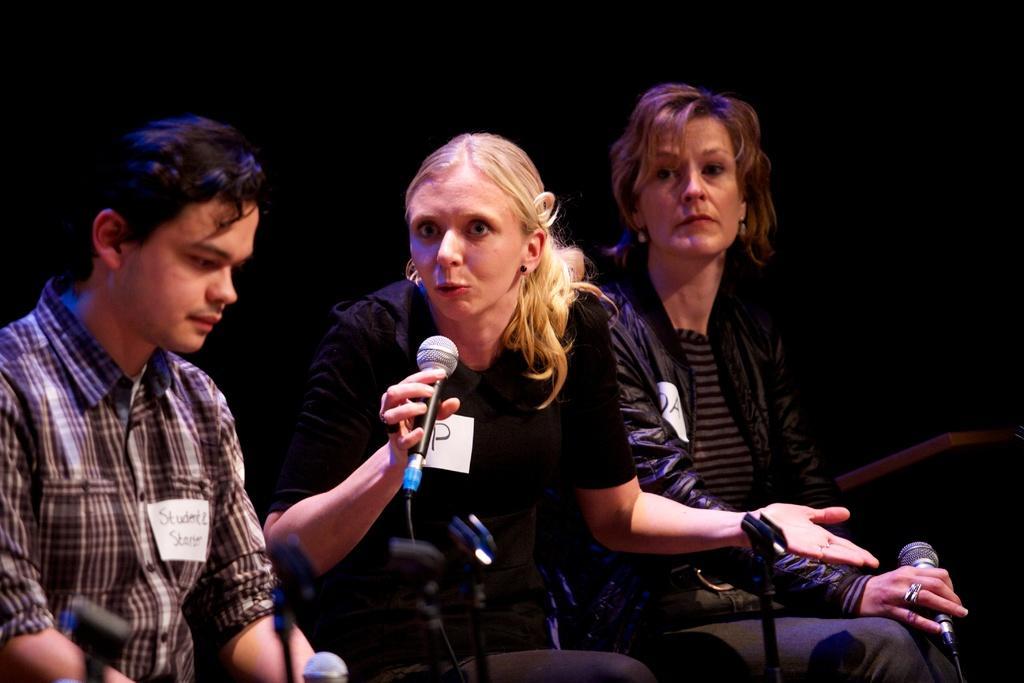Can you describe this image briefly? The woman in the middle of the picture wearing black t-shirt is holding a microphone in her hand and she is talking on the microphone. Beside her, the woman in black jacket is sitting on the chair and she is holding the microphone in her hand. On the left corner of the picture, the man in the check shirt is sitting on the chair. In the background, it is black in color. 